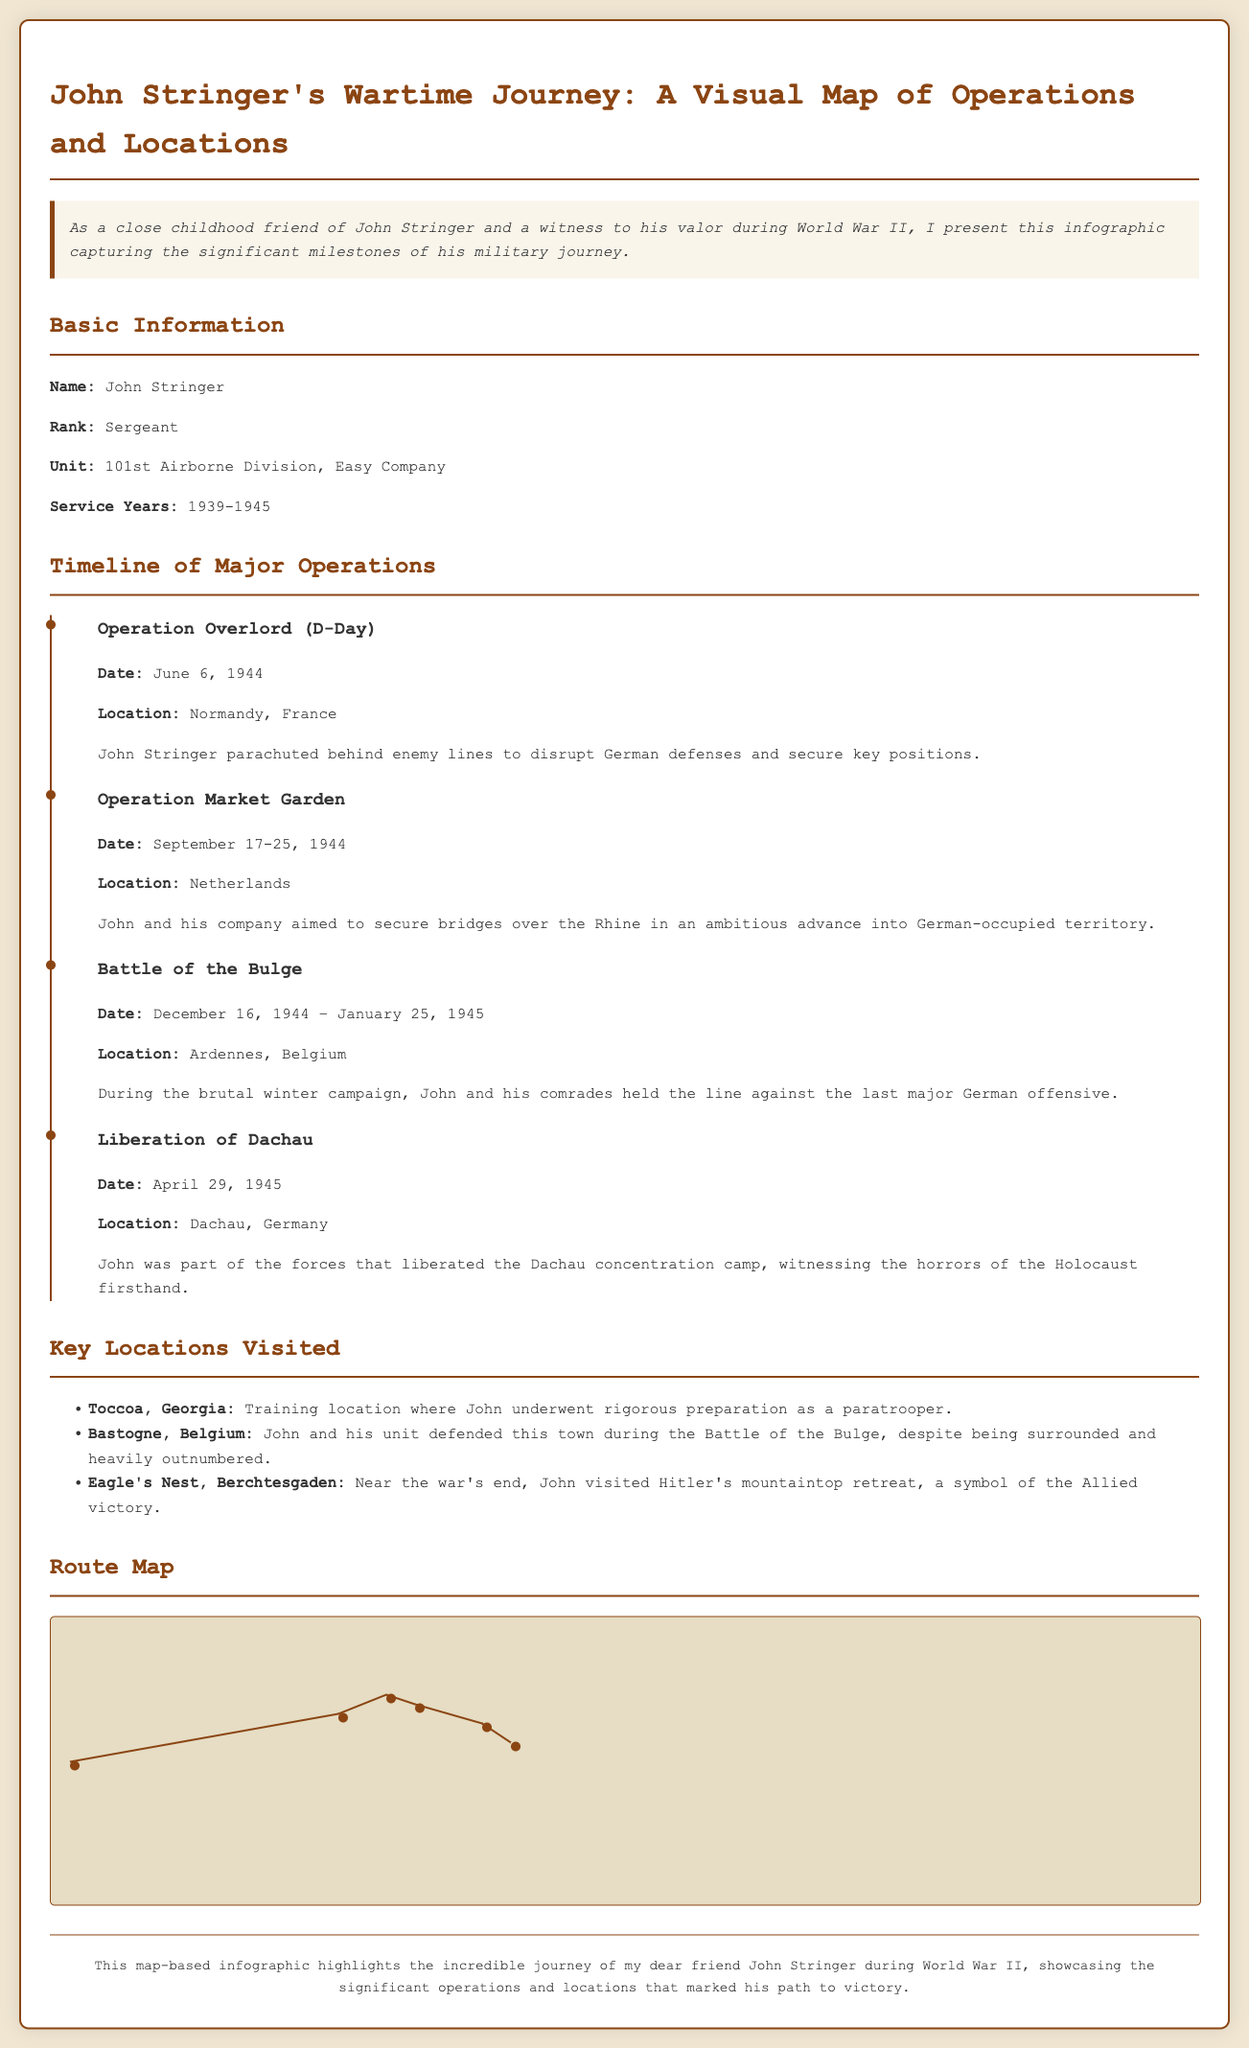What was John Stringer's rank? The document provides a section titled "Basic Information" that includes the rank of John Stringer.
Answer: Sergeant What operation took place on June 6, 1944? The document lists major operations with their corresponding dates. June 6, 1944, corresponds to Operation Overlord.
Answer: Operation Overlord In which year did John Stringer begin his service? The "Basic Information" section includes the service years of John Stringer, starting from 1939.
Answer: 1939 What was the location of the Battle of the Bulge? The timeline provides details on the major operations, including the location for the Battle of the Bulge.
Answer: Ardennes, Belgium How many major operations are listed in the infographic? The "Timeline of Major Operations" details four significant operations during John Stringer's service.
Answer: Four Which city did John Stringer train in? In the "Key Locations Visited" section, the training location for John Stringer is specified.
Answer: Toccoa, Georgia What was the last major operation listed? The timeline showcases John Stringer's last major operation, which relates to a significant historical event.
Answer: Liberation of Dachau What symbol did John visit near the war's end? The document mentions an important location visited by John towards the conclusion of the war, highlighting its significance.
Answer: Eagle's Nest, Berchtesgaden 